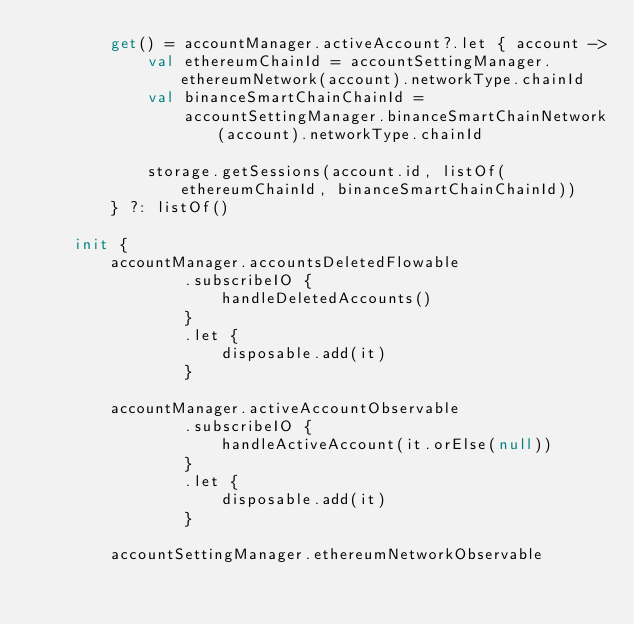<code> <loc_0><loc_0><loc_500><loc_500><_Kotlin_>        get() = accountManager.activeAccount?.let { account ->
            val ethereumChainId = accountSettingManager.ethereumNetwork(account).networkType.chainId
            val binanceSmartChainChainId =
                accountSettingManager.binanceSmartChainNetwork(account).networkType.chainId

            storage.getSessions(account.id, listOf(ethereumChainId, binanceSmartChainChainId))
        } ?: listOf()

    init {
        accountManager.accountsDeletedFlowable
                .subscribeIO {
                    handleDeletedAccounts()
                }
                .let {
                    disposable.add(it)
                }

        accountManager.activeAccountObservable
                .subscribeIO {
                    handleActiveAccount(it.orElse(null))
                }
                .let {
                    disposable.add(it)
                }

        accountSettingManager.ethereumNetworkObservable</code> 